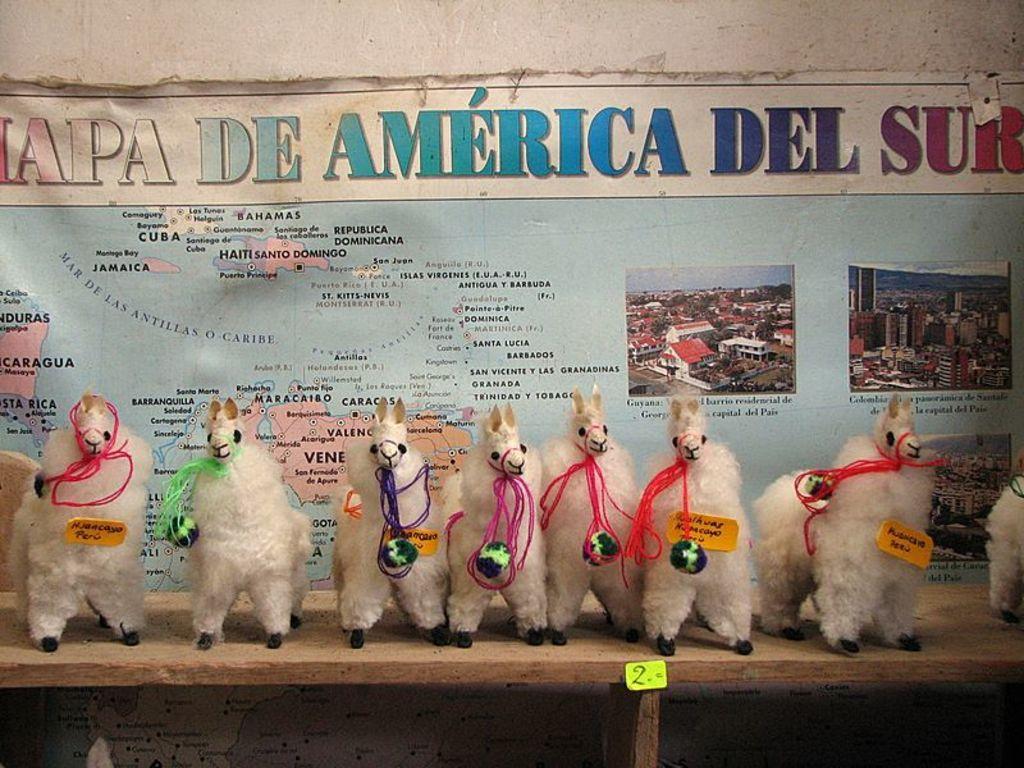Describe this image in one or two sentences. In the image there are llama toys on a shelf with a map behind it on the wall. 